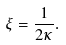Convert formula to latex. <formula><loc_0><loc_0><loc_500><loc_500>\xi = \frac { 1 } { 2 \kappa } .</formula> 